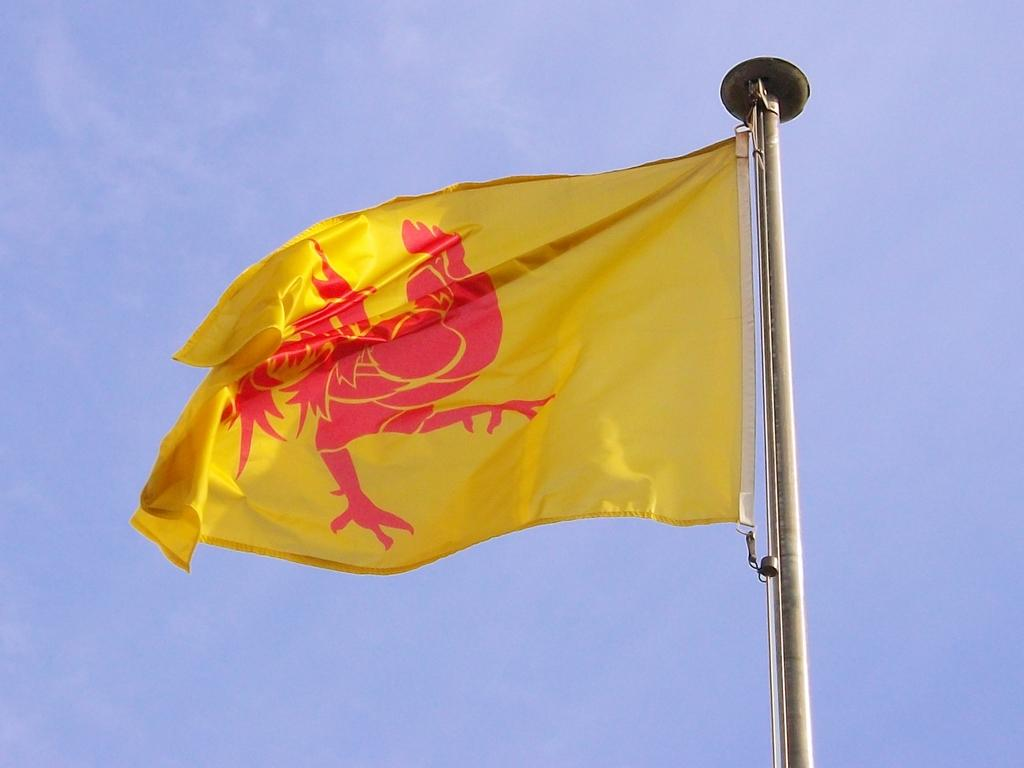What is the main object in the image? There is a pole in the image. What is attached to the pole? There is a yellow-colored flag on the pole. What can be seen in the sky in the image? The sky is visible in the image. What is featured on the flag? There is a logo on the flag. What type of cabbage is being used to paint the flag in the image? There is no cabbage or painting activity present in the image. The flag is already attached to the pole with a yellow color and a logo on it. 